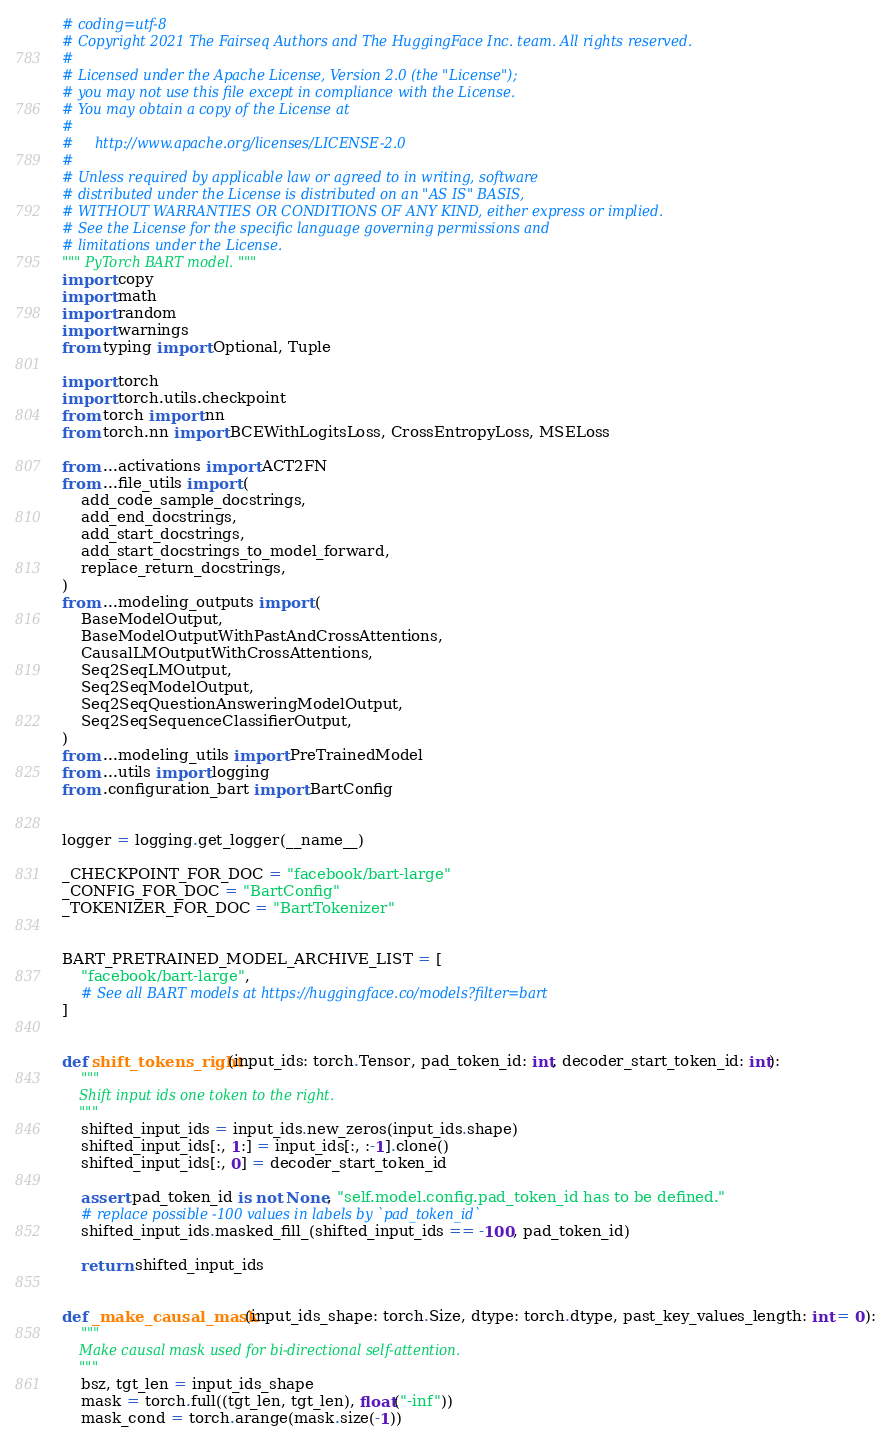Convert code to text. <code><loc_0><loc_0><loc_500><loc_500><_Python_># coding=utf-8
# Copyright 2021 The Fairseq Authors and The HuggingFace Inc. team. All rights reserved.
#
# Licensed under the Apache License, Version 2.0 (the "License");
# you may not use this file except in compliance with the License.
# You may obtain a copy of the License at
#
#     http://www.apache.org/licenses/LICENSE-2.0
#
# Unless required by applicable law or agreed to in writing, software
# distributed under the License is distributed on an "AS IS" BASIS,
# WITHOUT WARRANTIES OR CONDITIONS OF ANY KIND, either express or implied.
# See the License for the specific language governing permissions and
# limitations under the License.
""" PyTorch BART model. """
import copy
import math
import random
import warnings
from typing import Optional, Tuple

import torch
import torch.utils.checkpoint
from torch import nn
from torch.nn import BCEWithLogitsLoss, CrossEntropyLoss, MSELoss

from ...activations import ACT2FN
from ...file_utils import (
    add_code_sample_docstrings,
    add_end_docstrings,
    add_start_docstrings,
    add_start_docstrings_to_model_forward,
    replace_return_docstrings,
)
from ...modeling_outputs import (
    BaseModelOutput,
    BaseModelOutputWithPastAndCrossAttentions,
    CausalLMOutputWithCrossAttentions,
    Seq2SeqLMOutput,
    Seq2SeqModelOutput,
    Seq2SeqQuestionAnsweringModelOutput,
    Seq2SeqSequenceClassifierOutput,
)
from ...modeling_utils import PreTrainedModel
from ...utils import logging
from .configuration_bart import BartConfig


logger = logging.get_logger(__name__)

_CHECKPOINT_FOR_DOC = "facebook/bart-large"
_CONFIG_FOR_DOC = "BartConfig"
_TOKENIZER_FOR_DOC = "BartTokenizer"


BART_PRETRAINED_MODEL_ARCHIVE_LIST = [
    "facebook/bart-large",
    # See all BART models at https://huggingface.co/models?filter=bart
]


def shift_tokens_right(input_ids: torch.Tensor, pad_token_id: int, decoder_start_token_id: int):
    """
    Shift input ids one token to the right.
    """
    shifted_input_ids = input_ids.new_zeros(input_ids.shape)
    shifted_input_ids[:, 1:] = input_ids[:, :-1].clone()
    shifted_input_ids[:, 0] = decoder_start_token_id

    assert pad_token_id is not None, "self.model.config.pad_token_id has to be defined."
    # replace possible -100 values in labels by `pad_token_id`
    shifted_input_ids.masked_fill_(shifted_input_ids == -100, pad_token_id)

    return shifted_input_ids


def _make_causal_mask(input_ids_shape: torch.Size, dtype: torch.dtype, past_key_values_length: int = 0):
    """
    Make causal mask used for bi-directional self-attention.
    """
    bsz, tgt_len = input_ids_shape
    mask = torch.full((tgt_len, tgt_len), float("-inf"))
    mask_cond = torch.arange(mask.size(-1))</code> 